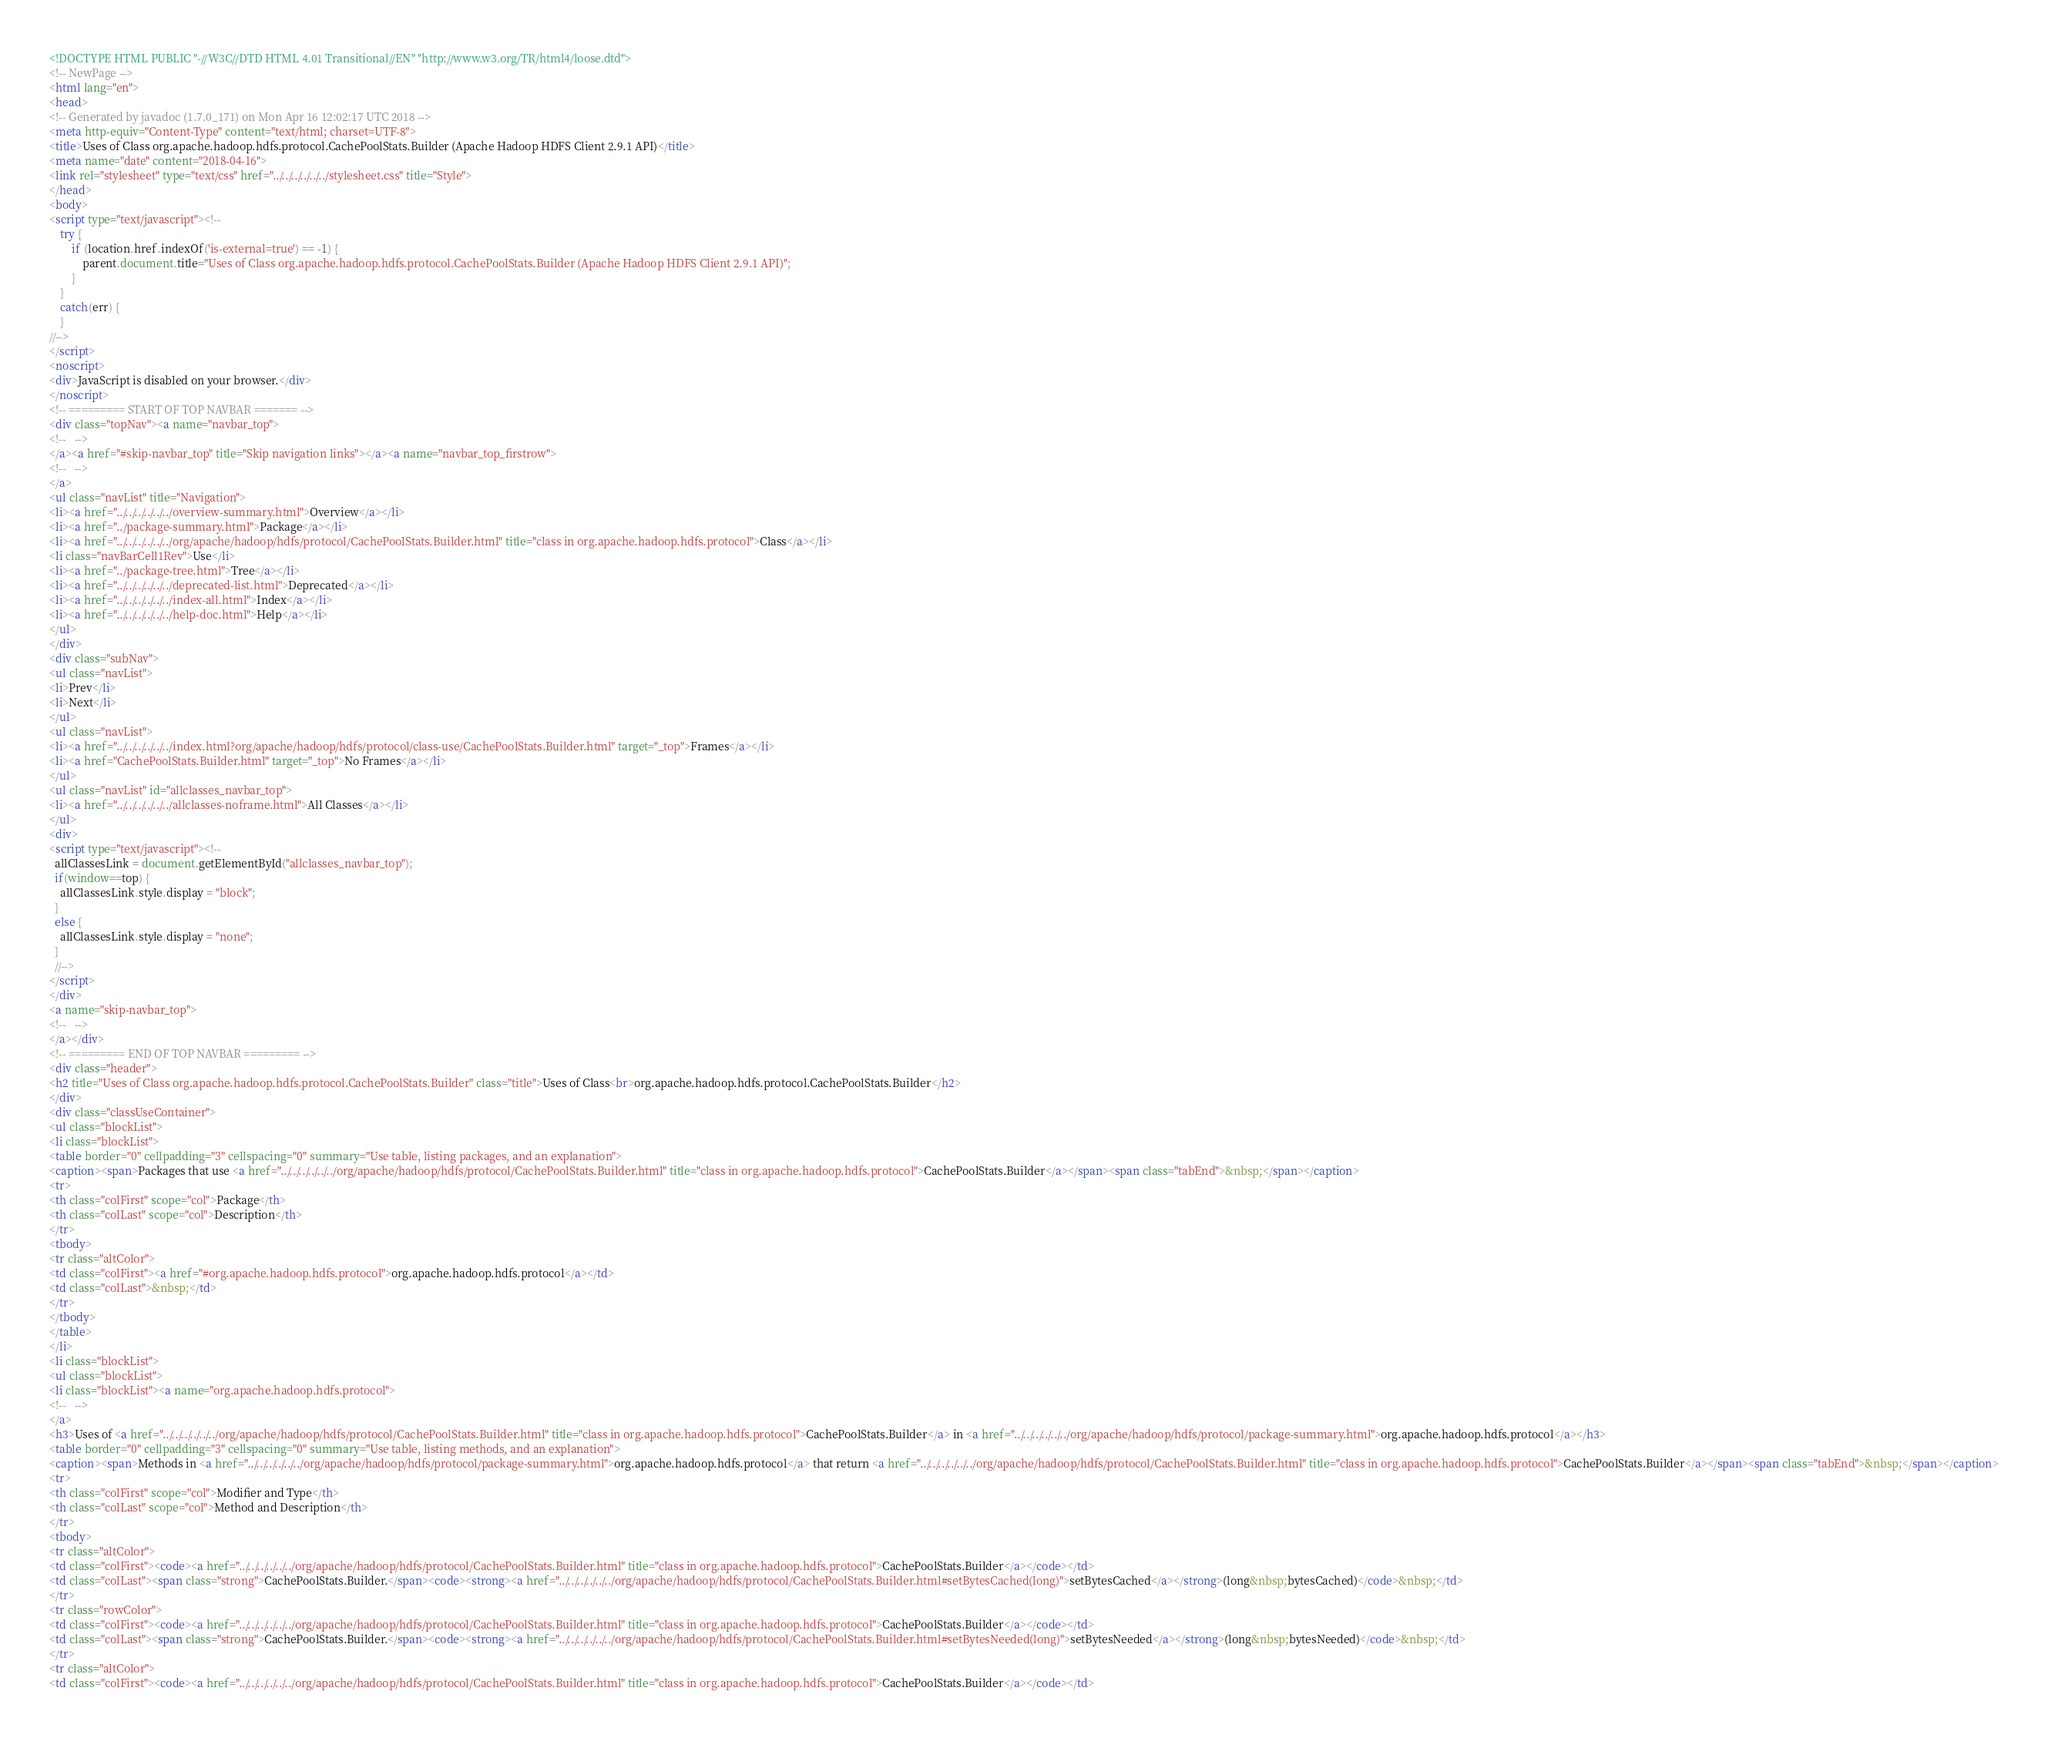Convert code to text. <code><loc_0><loc_0><loc_500><loc_500><_HTML_><!DOCTYPE HTML PUBLIC "-//W3C//DTD HTML 4.01 Transitional//EN" "http://www.w3.org/TR/html4/loose.dtd">
<!-- NewPage -->
<html lang="en">
<head>
<!-- Generated by javadoc (1.7.0_171) on Mon Apr 16 12:02:17 UTC 2018 -->
<meta http-equiv="Content-Type" content="text/html; charset=UTF-8">
<title>Uses of Class org.apache.hadoop.hdfs.protocol.CachePoolStats.Builder (Apache Hadoop HDFS Client 2.9.1 API)</title>
<meta name="date" content="2018-04-16">
<link rel="stylesheet" type="text/css" href="../../../../../../stylesheet.css" title="Style">
</head>
<body>
<script type="text/javascript"><!--
    try {
        if (location.href.indexOf('is-external=true') == -1) {
            parent.document.title="Uses of Class org.apache.hadoop.hdfs.protocol.CachePoolStats.Builder (Apache Hadoop HDFS Client 2.9.1 API)";
        }
    }
    catch(err) {
    }
//-->
</script>
<noscript>
<div>JavaScript is disabled on your browser.</div>
</noscript>
<!-- ========= START OF TOP NAVBAR ======= -->
<div class="topNav"><a name="navbar_top">
<!--   -->
</a><a href="#skip-navbar_top" title="Skip navigation links"></a><a name="navbar_top_firstrow">
<!--   -->
</a>
<ul class="navList" title="Navigation">
<li><a href="../../../../../../overview-summary.html">Overview</a></li>
<li><a href="../package-summary.html">Package</a></li>
<li><a href="../../../../../../org/apache/hadoop/hdfs/protocol/CachePoolStats.Builder.html" title="class in org.apache.hadoop.hdfs.protocol">Class</a></li>
<li class="navBarCell1Rev">Use</li>
<li><a href="../package-tree.html">Tree</a></li>
<li><a href="../../../../../../deprecated-list.html">Deprecated</a></li>
<li><a href="../../../../../../index-all.html">Index</a></li>
<li><a href="../../../../../../help-doc.html">Help</a></li>
</ul>
</div>
<div class="subNav">
<ul class="navList">
<li>Prev</li>
<li>Next</li>
</ul>
<ul class="navList">
<li><a href="../../../../../../index.html?org/apache/hadoop/hdfs/protocol/class-use/CachePoolStats.Builder.html" target="_top">Frames</a></li>
<li><a href="CachePoolStats.Builder.html" target="_top">No Frames</a></li>
</ul>
<ul class="navList" id="allclasses_navbar_top">
<li><a href="../../../../../../allclasses-noframe.html">All Classes</a></li>
</ul>
<div>
<script type="text/javascript"><!--
  allClassesLink = document.getElementById("allclasses_navbar_top");
  if(window==top) {
    allClassesLink.style.display = "block";
  }
  else {
    allClassesLink.style.display = "none";
  }
  //-->
</script>
</div>
<a name="skip-navbar_top">
<!--   -->
</a></div>
<!-- ========= END OF TOP NAVBAR ========= -->
<div class="header">
<h2 title="Uses of Class org.apache.hadoop.hdfs.protocol.CachePoolStats.Builder" class="title">Uses of Class<br>org.apache.hadoop.hdfs.protocol.CachePoolStats.Builder</h2>
</div>
<div class="classUseContainer">
<ul class="blockList">
<li class="blockList">
<table border="0" cellpadding="3" cellspacing="0" summary="Use table, listing packages, and an explanation">
<caption><span>Packages that use <a href="../../../../../../org/apache/hadoop/hdfs/protocol/CachePoolStats.Builder.html" title="class in org.apache.hadoop.hdfs.protocol">CachePoolStats.Builder</a></span><span class="tabEnd">&nbsp;</span></caption>
<tr>
<th class="colFirst" scope="col">Package</th>
<th class="colLast" scope="col">Description</th>
</tr>
<tbody>
<tr class="altColor">
<td class="colFirst"><a href="#org.apache.hadoop.hdfs.protocol">org.apache.hadoop.hdfs.protocol</a></td>
<td class="colLast">&nbsp;</td>
</tr>
</tbody>
</table>
</li>
<li class="blockList">
<ul class="blockList">
<li class="blockList"><a name="org.apache.hadoop.hdfs.protocol">
<!--   -->
</a>
<h3>Uses of <a href="../../../../../../org/apache/hadoop/hdfs/protocol/CachePoolStats.Builder.html" title="class in org.apache.hadoop.hdfs.protocol">CachePoolStats.Builder</a> in <a href="../../../../../../org/apache/hadoop/hdfs/protocol/package-summary.html">org.apache.hadoop.hdfs.protocol</a></h3>
<table border="0" cellpadding="3" cellspacing="0" summary="Use table, listing methods, and an explanation">
<caption><span>Methods in <a href="../../../../../../org/apache/hadoop/hdfs/protocol/package-summary.html">org.apache.hadoop.hdfs.protocol</a> that return <a href="../../../../../../org/apache/hadoop/hdfs/protocol/CachePoolStats.Builder.html" title="class in org.apache.hadoop.hdfs.protocol">CachePoolStats.Builder</a></span><span class="tabEnd">&nbsp;</span></caption>
<tr>
<th class="colFirst" scope="col">Modifier and Type</th>
<th class="colLast" scope="col">Method and Description</th>
</tr>
<tbody>
<tr class="altColor">
<td class="colFirst"><code><a href="../../../../../../org/apache/hadoop/hdfs/protocol/CachePoolStats.Builder.html" title="class in org.apache.hadoop.hdfs.protocol">CachePoolStats.Builder</a></code></td>
<td class="colLast"><span class="strong">CachePoolStats.Builder.</span><code><strong><a href="../../../../../../org/apache/hadoop/hdfs/protocol/CachePoolStats.Builder.html#setBytesCached(long)">setBytesCached</a></strong>(long&nbsp;bytesCached)</code>&nbsp;</td>
</tr>
<tr class="rowColor">
<td class="colFirst"><code><a href="../../../../../../org/apache/hadoop/hdfs/protocol/CachePoolStats.Builder.html" title="class in org.apache.hadoop.hdfs.protocol">CachePoolStats.Builder</a></code></td>
<td class="colLast"><span class="strong">CachePoolStats.Builder.</span><code><strong><a href="../../../../../../org/apache/hadoop/hdfs/protocol/CachePoolStats.Builder.html#setBytesNeeded(long)">setBytesNeeded</a></strong>(long&nbsp;bytesNeeded)</code>&nbsp;</td>
</tr>
<tr class="altColor">
<td class="colFirst"><code><a href="../../../../../../org/apache/hadoop/hdfs/protocol/CachePoolStats.Builder.html" title="class in org.apache.hadoop.hdfs.protocol">CachePoolStats.Builder</a></code></td></code> 